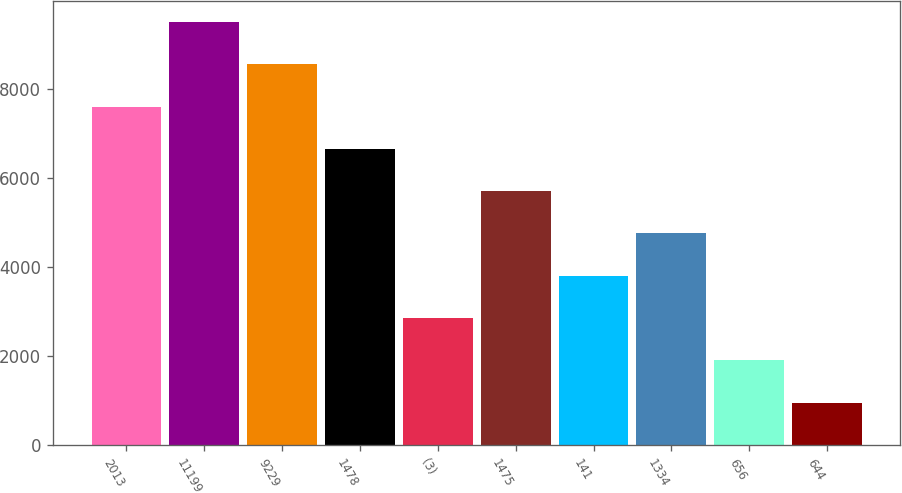Convert chart to OTSL. <chart><loc_0><loc_0><loc_500><loc_500><bar_chart><fcel>2013<fcel>11199<fcel>9229<fcel>1478<fcel>(3)<fcel>1475<fcel>141<fcel>1334<fcel>656<fcel>644<nl><fcel>7609.75<fcel>9512.01<fcel>8560.88<fcel>6658.62<fcel>2854.1<fcel>5707.49<fcel>3805.23<fcel>4756.36<fcel>1902.97<fcel>951.84<nl></chart> 